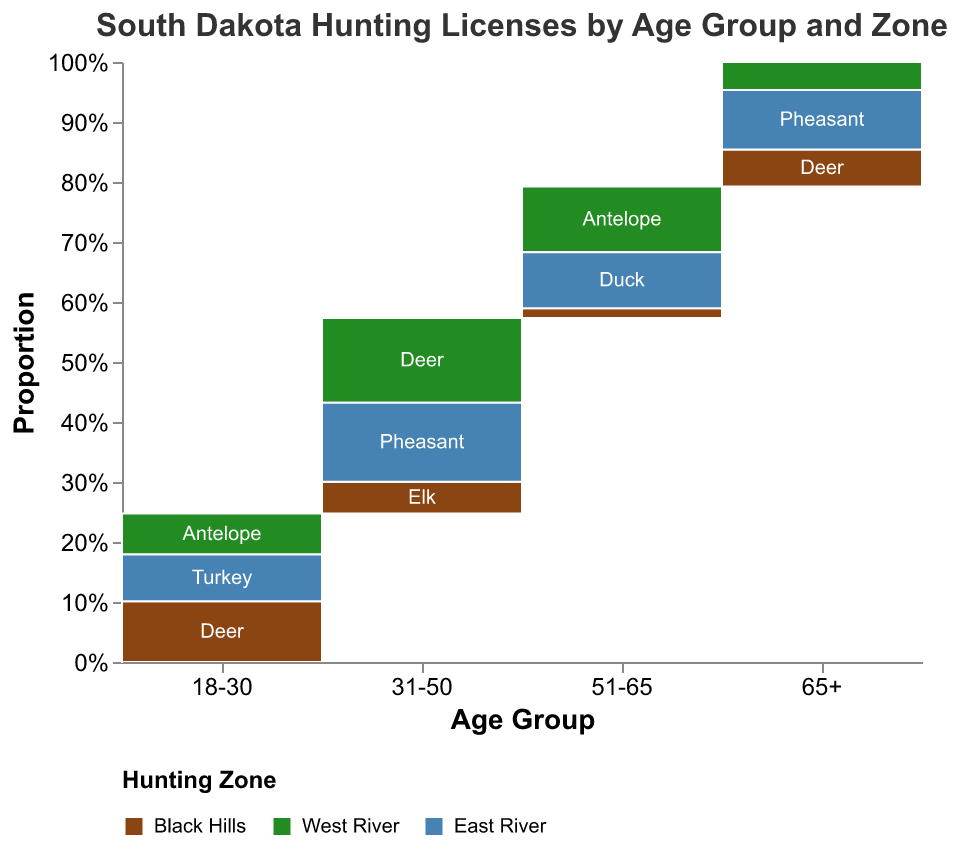What's the title of the figure? The title is usually located at the top of the figure in a larger font size. In this case, it states "South Dakota Hunting Licenses by Age Group and Zone" indicating the topic of the visualization.
Answer: South Dakota Hunting Licenses by Age Group and Zone What are the age groups represented in the figure? The x-axis usually lists the categories being compared. Here, it shows age groups: 18-30, 31-50, 51-65, and 65+.
Answer: 18-30, 31-50, 51-65, 65+ Which hunting zone has the color brown in the figure? The legend at the bottom of the figure links colors to the hunting zones. The color brown corresponds to the Black Hills hunting zone.
Answer: Black Hills Which age group has the highest total number of hunting licenses issued? By summing up the proportions represented by all the sections in each age group, the age group with the largest accumulated proportion indicates the highest total number of licenses. In this case, "31-50" has the highest.
Answer: 31-50 How many different license types are shown in the figure? By counting the distinct labels within the sections of the figure, we can see that the license types are Deer, Antelope, Turkey, Elk, Pheasant, Mountain Lion, and Duck, giving a total of 7.
Answer: 7 Which license type is most common in the 18-30 age group? By looking at the sections within the 18-30 age group, the largest section corresponds to the Deer license in the Black Hills zone.
Answer: Deer In the age group 51-65, which license type is found in the Black Hills zone, and what is the approximate proportion? Observing the sections corresponding to the age group 51-65 and filtering by the Black Hills color (brown), the Mountain Lion license type is represented, making up roughly a small proportion of the total age group section.
Answer: Mountain Lion Are there more hunting licenses issued for Antelope in the West River zone or Pheasant in the East River zone for the age group 51-65? By comparing the sizes of the respective sections for the age group 51-65, the section for Antelope in West River is larger than the Pheasant in East River.
Answer: Antelope in West River Combine license counts: What's the sum of Deer and Elk licenses issued in the Black Hills zone? First, identify the sections for Deer and Elk in the Black Hills zone, then add their counts: 145 (Deer, 18-30) and 89 (Deer, 65+) plus 76 (Elk, 31-50) gives a total of 310.
Answer: 310 What's the largest proportion of a single license type in the West River zone, and to which age group does it belong? By reviewing the proportions of various license types within the West River zone sections, the largest single proportion is from Deer in the 31-50 age group.
Answer: Deer in 31-50 